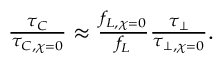Convert formula to latex. <formula><loc_0><loc_0><loc_500><loc_500>\begin{array} { r } { \frac { \tau _ { C } } { \tau _ { C , \chi = 0 } } \approx \frac { f _ { L , \chi = 0 } } { f _ { L } } \frac { \tau _ { \perp } } { \tau _ { \perp , \chi = 0 } } . } \end{array}</formula> 